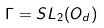Convert formula to latex. <formula><loc_0><loc_0><loc_500><loc_500>\Gamma = S L _ { 2 } ( O _ { d } )</formula> 